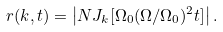<formula> <loc_0><loc_0><loc_500><loc_500>r ( k , t ) = \left | N J _ { k } [ \Omega _ { 0 } ( \Omega / \Omega _ { 0 } ) ^ { 2 } t ] \right | .</formula> 